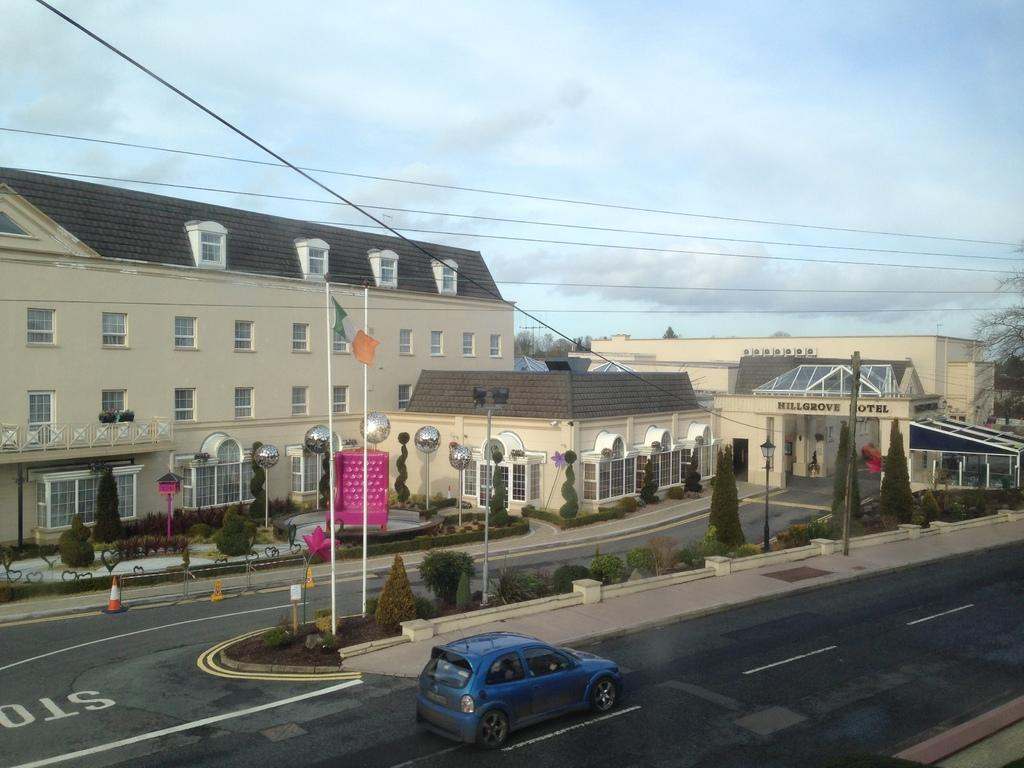What color is the car on the road in the image? The car on the road is blue. What can be seen behind the car in the image? There is a yellow house behind the car. How many windows does the house have? The house has many windows. What type of roof does the house have? The house has a tile roof. What is the color of the sky in the image? The sky is blue. What else can be seen in the sky? There are clouds visible in the sky. Where are the shoes placed in the image? There are no shoes present in the image. What type of waste is being disposed of in the image? There is no waste disposal visible in the image. What government policies are being discussed in the image? There is no discussion of government policies in the image. 